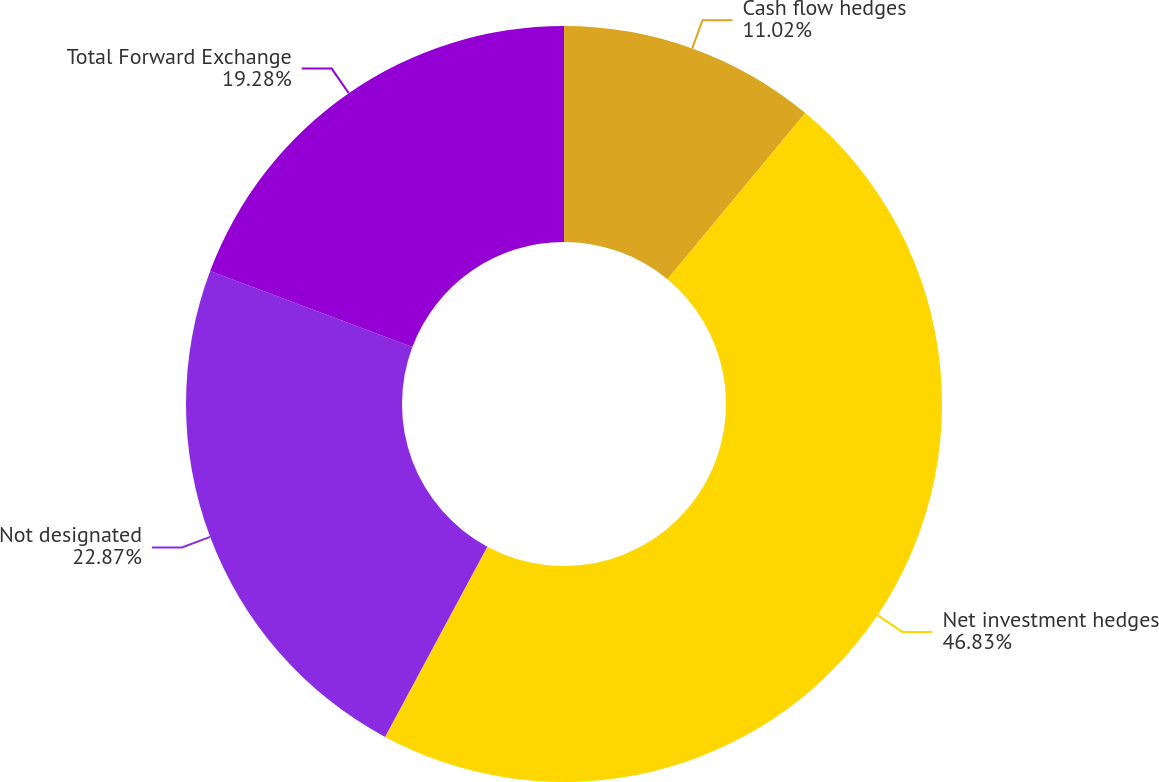Convert chart. <chart><loc_0><loc_0><loc_500><loc_500><pie_chart><fcel>Cash flow hedges<fcel>Net investment hedges<fcel>Not designated<fcel>Total Forward Exchange<nl><fcel>11.02%<fcel>46.83%<fcel>22.87%<fcel>19.28%<nl></chart> 